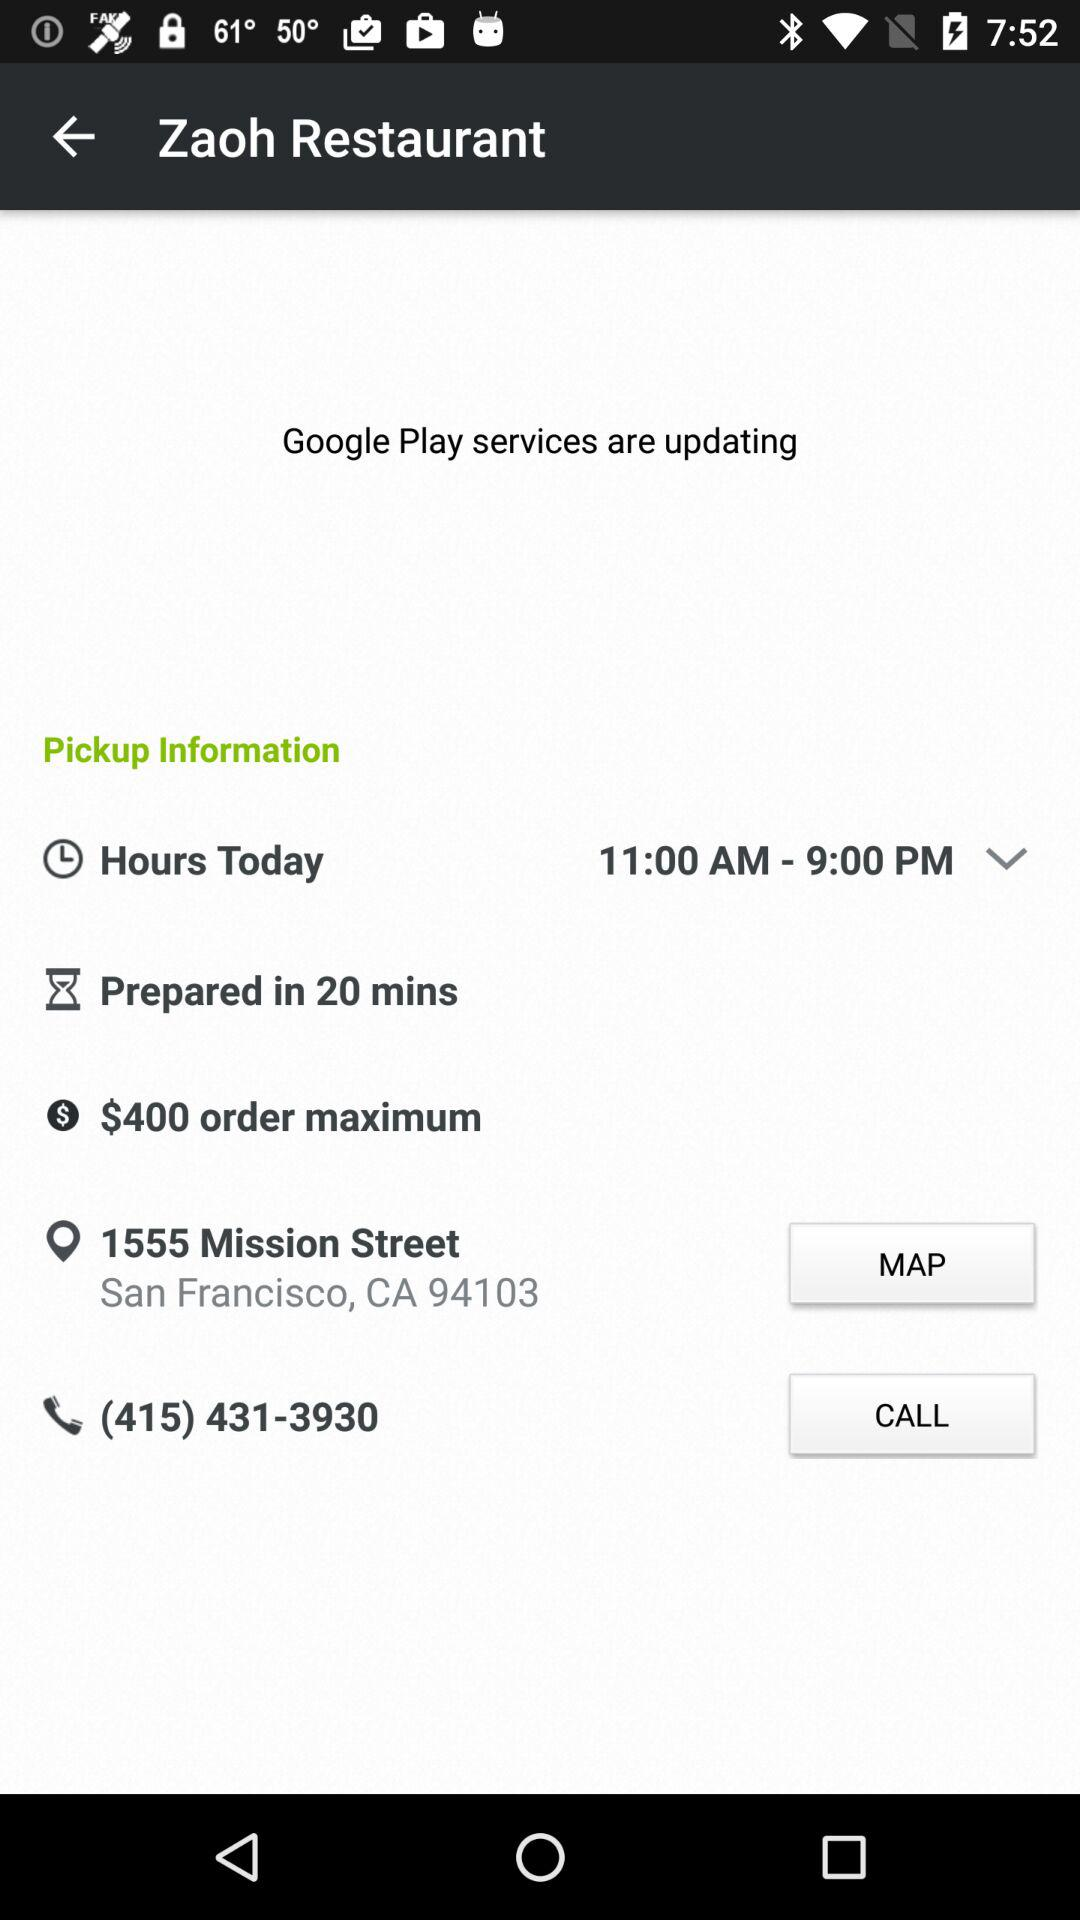What's the address? The address is 1555 Mission Street, San Francisco, CA 94103. 